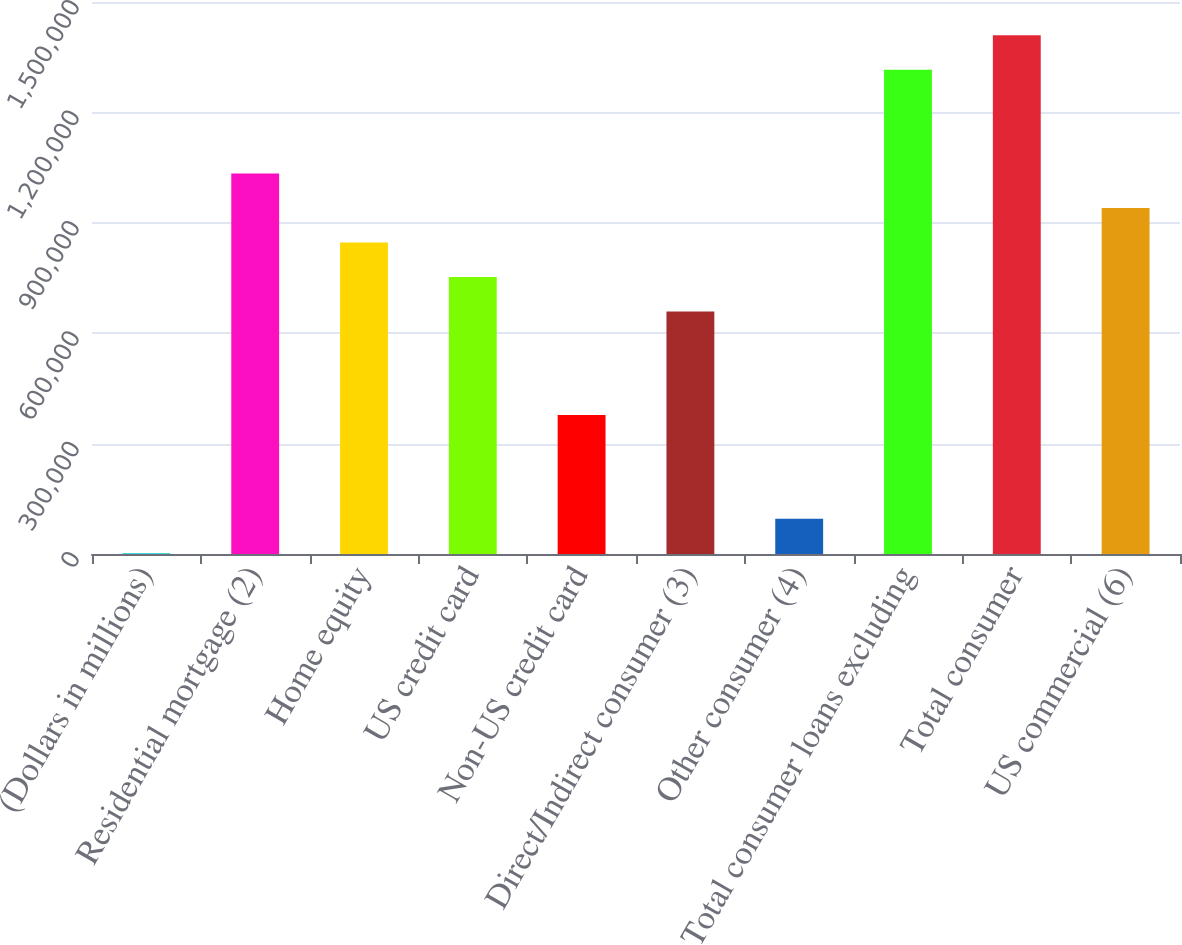Convert chart. <chart><loc_0><loc_0><loc_500><loc_500><bar_chart><fcel>(Dollars in millions)<fcel>Residential mortgage (2)<fcel>Home equity<fcel>US credit card<fcel>Non-US credit card<fcel>Direct/Indirect consumer (3)<fcel>Other consumer (4)<fcel>Total consumer loans excluding<fcel>Total consumer<fcel>US commercial (6)<nl><fcel>2010<fcel>1.03428e+06<fcel>846597<fcel>752754<fcel>377382<fcel>658911<fcel>95853<fcel>1.31581e+06<fcel>1.40966e+06<fcel>940440<nl></chart> 